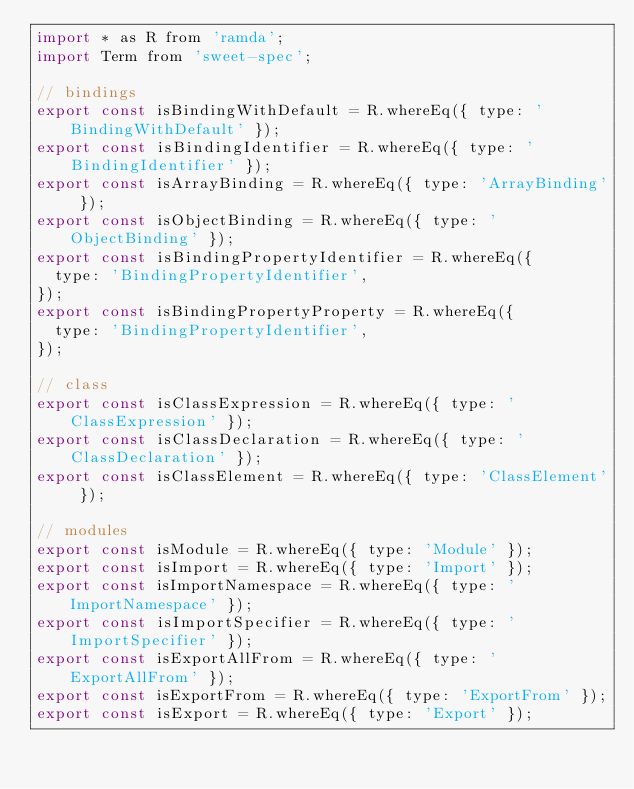<code> <loc_0><loc_0><loc_500><loc_500><_JavaScript_>import * as R from 'ramda';
import Term from 'sweet-spec';

// bindings
export const isBindingWithDefault = R.whereEq({ type: 'BindingWithDefault' });
export const isBindingIdentifier = R.whereEq({ type: 'BindingIdentifier' });
export const isArrayBinding = R.whereEq({ type: 'ArrayBinding' });
export const isObjectBinding = R.whereEq({ type: 'ObjectBinding' });
export const isBindingPropertyIdentifier = R.whereEq({
  type: 'BindingPropertyIdentifier',
});
export const isBindingPropertyProperty = R.whereEq({
  type: 'BindingPropertyIdentifier',
});

// class
export const isClassExpression = R.whereEq({ type: 'ClassExpression' });
export const isClassDeclaration = R.whereEq({ type: 'ClassDeclaration' });
export const isClassElement = R.whereEq({ type: 'ClassElement' });

// modules
export const isModule = R.whereEq({ type: 'Module' });
export const isImport = R.whereEq({ type: 'Import' });
export const isImportNamespace = R.whereEq({ type: 'ImportNamespace' });
export const isImportSpecifier = R.whereEq({ type: 'ImportSpecifier' });
export const isExportAllFrom = R.whereEq({ type: 'ExportAllFrom' });
export const isExportFrom = R.whereEq({ type: 'ExportFrom' });
export const isExport = R.whereEq({ type: 'Export' });</code> 